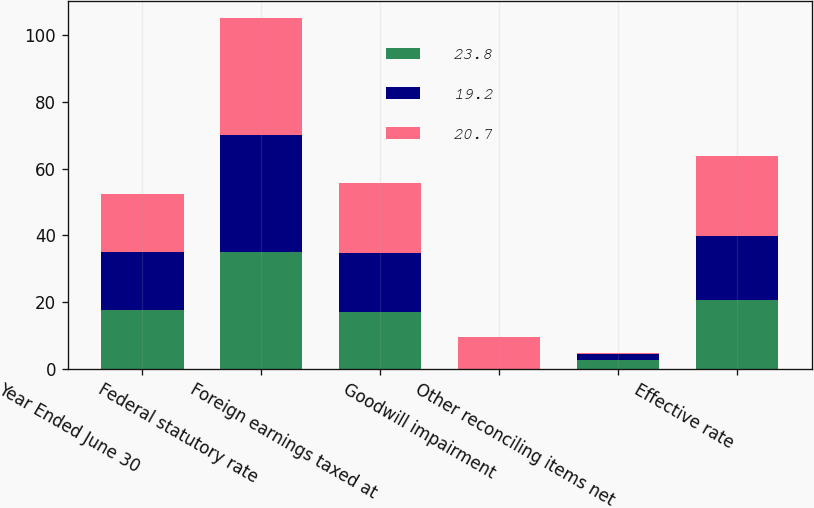<chart> <loc_0><loc_0><loc_500><loc_500><stacked_bar_chart><ecel><fcel>Year Ended June 30<fcel>Federal statutory rate<fcel>Foreign earnings taxed at<fcel>Goodwill impairment<fcel>Other reconciling items net<fcel>Effective rate<nl><fcel>23.8<fcel>17.5<fcel>35<fcel>17.1<fcel>0<fcel>2.8<fcel>20.7<nl><fcel>19.2<fcel>17.5<fcel>35<fcel>17.5<fcel>0<fcel>1.7<fcel>19.2<nl><fcel>20.7<fcel>17.5<fcel>35<fcel>21.1<fcel>9.7<fcel>0.2<fcel>23.8<nl></chart> 